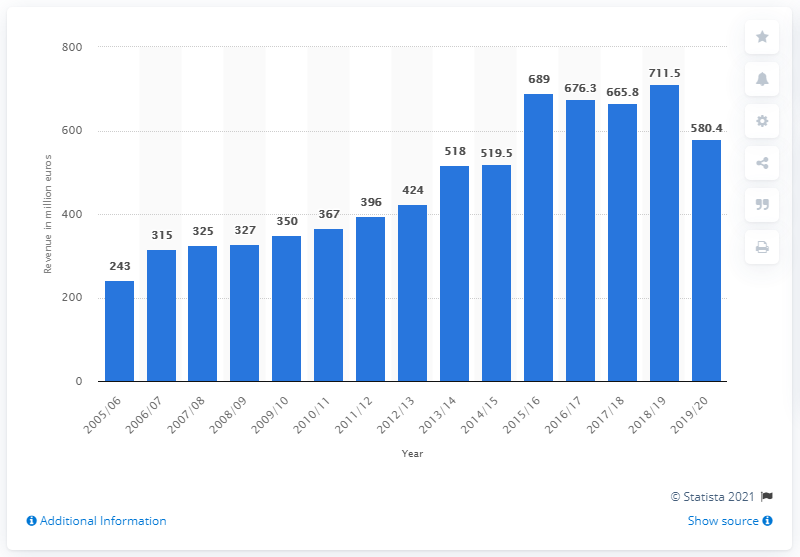Outline some significant characteristics in this image. During the 2019/20 season, Manchester United generated a revenue of 580.4 million pounds. 